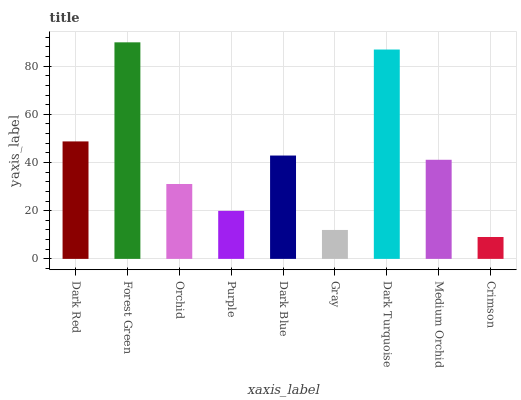Is Crimson the minimum?
Answer yes or no. Yes. Is Forest Green the maximum?
Answer yes or no. Yes. Is Orchid the minimum?
Answer yes or no. No. Is Orchid the maximum?
Answer yes or no. No. Is Forest Green greater than Orchid?
Answer yes or no. Yes. Is Orchid less than Forest Green?
Answer yes or no. Yes. Is Orchid greater than Forest Green?
Answer yes or no. No. Is Forest Green less than Orchid?
Answer yes or no. No. Is Medium Orchid the high median?
Answer yes or no. Yes. Is Medium Orchid the low median?
Answer yes or no. Yes. Is Gray the high median?
Answer yes or no. No. Is Dark Turquoise the low median?
Answer yes or no. No. 